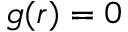<formula> <loc_0><loc_0><loc_500><loc_500>g ( r ) = 0</formula> 